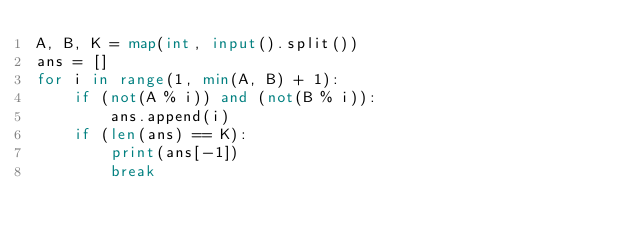Convert code to text. <code><loc_0><loc_0><loc_500><loc_500><_Python_>A, B, K = map(int, input().split())
ans = []
for i in range(1, min(A, B) + 1):
    if (not(A % i)) and (not(B % i)):
        ans.append(i)
    if (len(ans) == K):
        print(ans[-1])
        break
</code> 